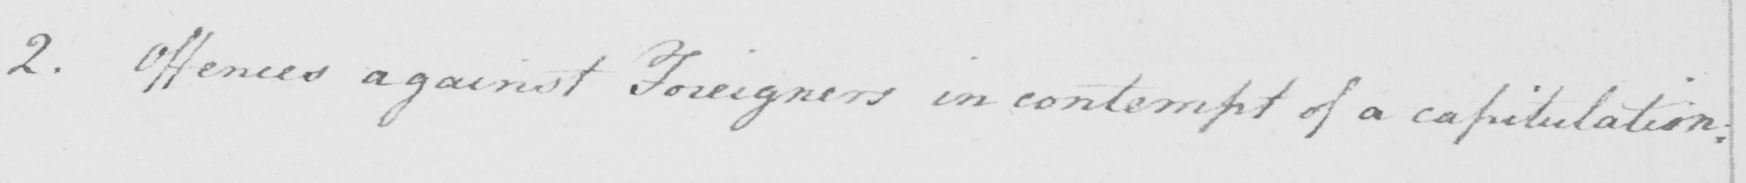Please provide the text content of this handwritten line. 2 . Offences against Foreigners in contempt of a capitulation : 